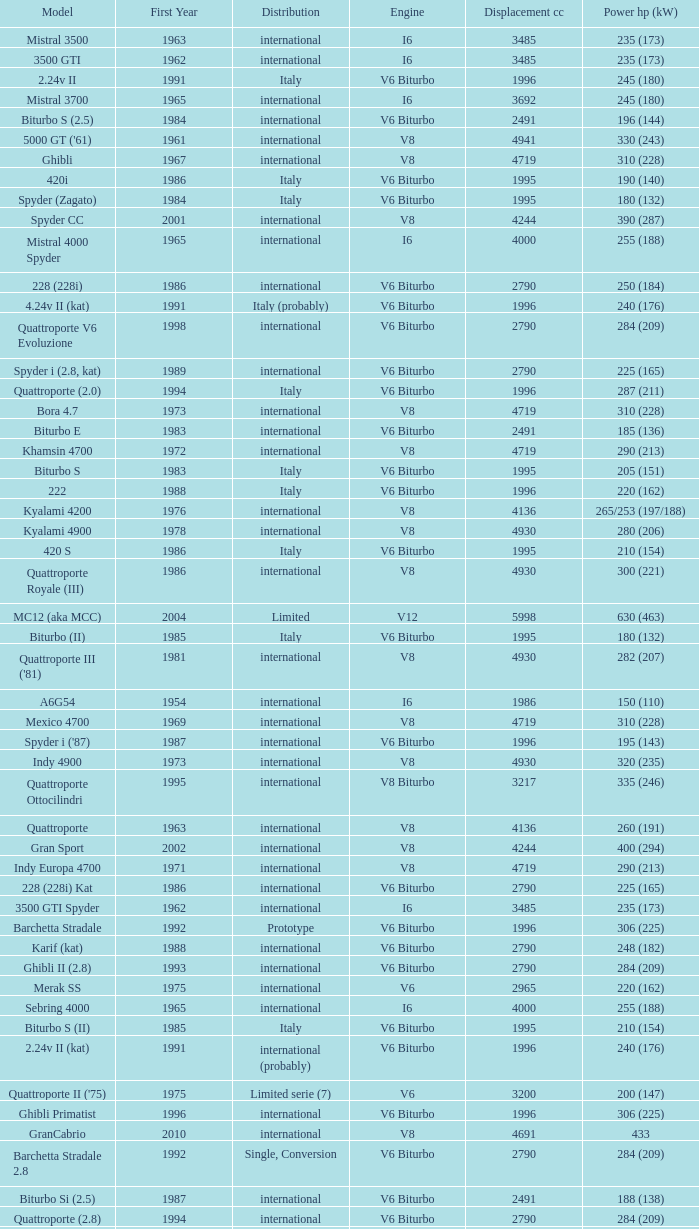What is Power HP (kW), when First Year is greater than 1965, when Distribution is "International", when Engine is V6 Biturbo, and when Model is "425"? 200 (147). 